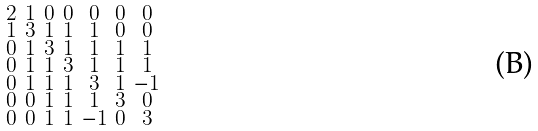<formula> <loc_0><loc_0><loc_500><loc_500>\begin{smallmatrix} 2 & 1 & 0 & 0 & 0 & 0 & 0 \\ 1 & 3 & 1 & 1 & 1 & 0 & 0 \\ 0 & 1 & 3 & 1 & 1 & 1 & 1 \\ 0 & 1 & 1 & 3 & 1 & 1 & 1 \\ 0 & 1 & 1 & 1 & 3 & 1 & - 1 \\ 0 & 0 & 1 & 1 & 1 & 3 & 0 \\ 0 & 0 & 1 & 1 & - 1 & 0 & 3 \end{smallmatrix}</formula> 